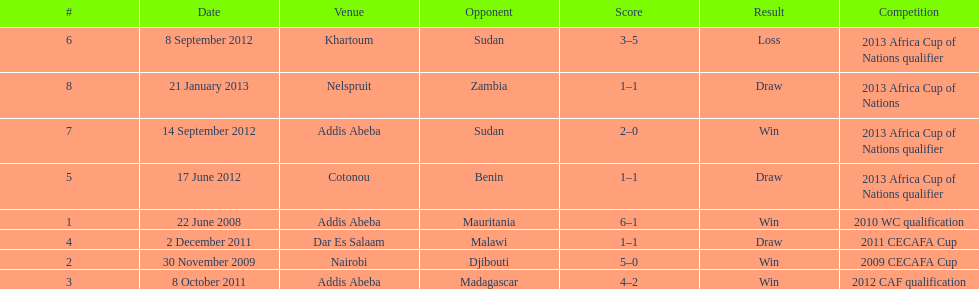True or false? in comparison, the ethiopian national team has more draws than wins. False. 